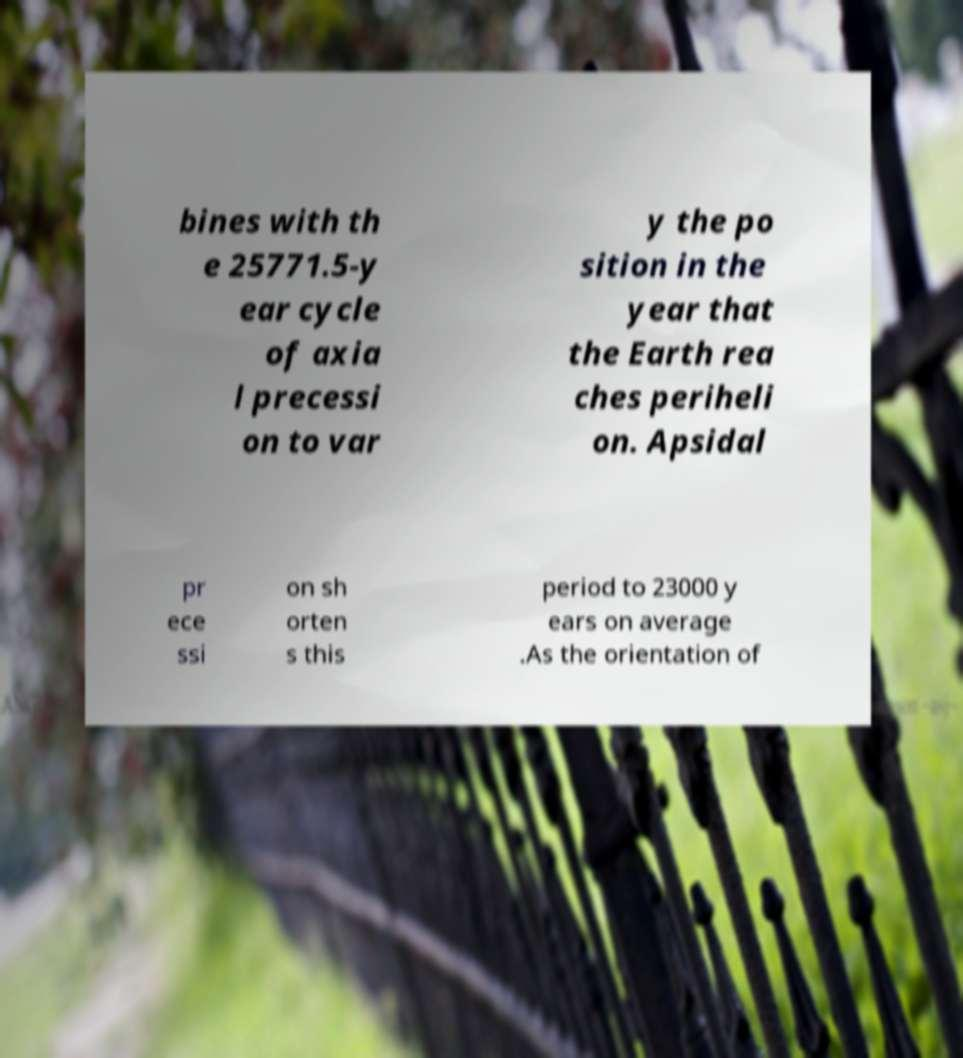Can you read and provide the text displayed in the image?This photo seems to have some interesting text. Can you extract and type it out for me? bines with th e 25771.5-y ear cycle of axia l precessi on to var y the po sition in the year that the Earth rea ches periheli on. Apsidal pr ece ssi on sh orten s this period to 23000 y ears on average .As the orientation of 